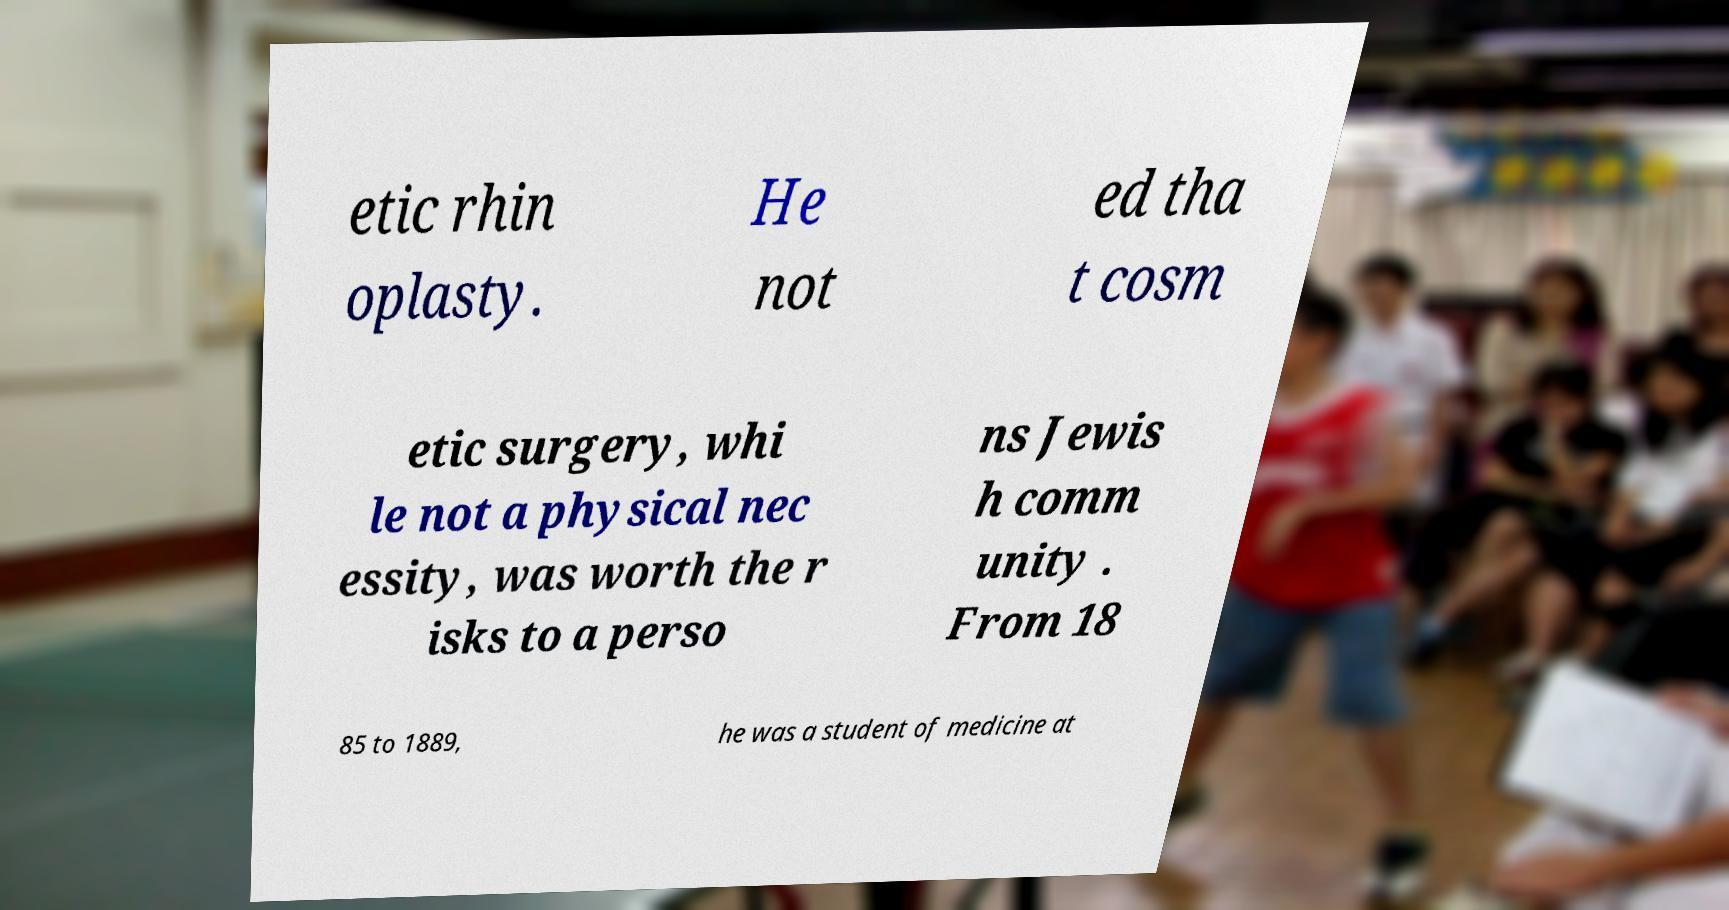Can you read and provide the text displayed in the image?This photo seems to have some interesting text. Can you extract and type it out for me? etic rhin oplasty. He not ed tha t cosm etic surgery, whi le not a physical nec essity, was worth the r isks to a perso ns Jewis h comm unity . From 18 85 to 1889, he was a student of medicine at 